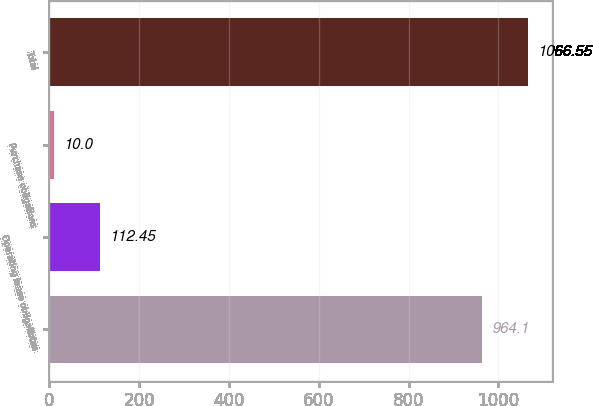Convert chart. <chart><loc_0><loc_0><loc_500><loc_500><bar_chart><fcel>Notes<fcel>Operating lease obligations<fcel>Purchase obligations<fcel>Total<nl><fcel>964.1<fcel>112.45<fcel>10<fcel>1066.55<nl></chart> 